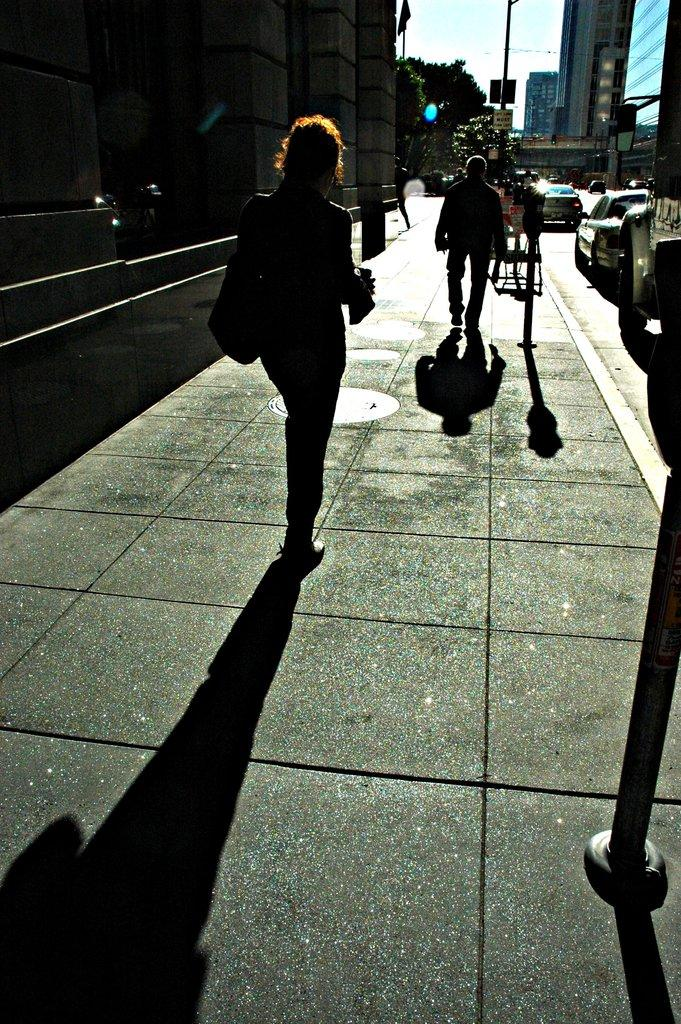What are the people in the image doing? The people in the image are walking on the walkway. What else can be seen in the image besides the people? There are cars, trees, a pole, a building, and the sky visible in the background of the image. What type of loaf is being smashed by the cars in the image? There are no loaves or smashing in the image; it features people walking and various other elements. 